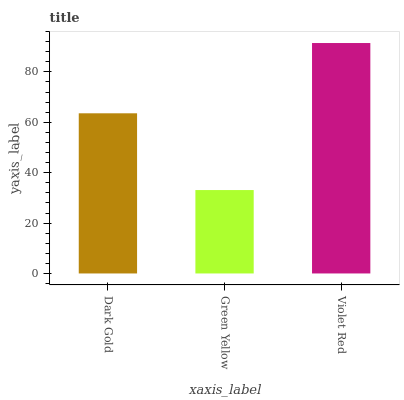Is Green Yellow the minimum?
Answer yes or no. Yes. Is Violet Red the maximum?
Answer yes or no. Yes. Is Violet Red the minimum?
Answer yes or no. No. Is Green Yellow the maximum?
Answer yes or no. No. Is Violet Red greater than Green Yellow?
Answer yes or no. Yes. Is Green Yellow less than Violet Red?
Answer yes or no. Yes. Is Green Yellow greater than Violet Red?
Answer yes or no. No. Is Violet Red less than Green Yellow?
Answer yes or no. No. Is Dark Gold the high median?
Answer yes or no. Yes. Is Dark Gold the low median?
Answer yes or no. Yes. Is Violet Red the high median?
Answer yes or no. No. Is Violet Red the low median?
Answer yes or no. No. 